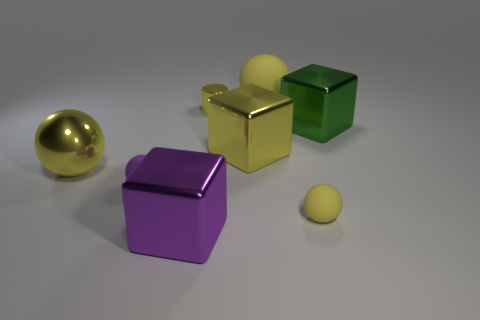There is a green metallic cube; is its size the same as the shiny object that is behind the big green shiny thing?
Your answer should be very brief. No. Are there more metal cylinders left of the tiny shiny cylinder than big yellow rubber balls?
Provide a short and direct response. No. There is a purple cube that is made of the same material as the big yellow cube; what is its size?
Make the answer very short. Large. Are there any metal cubes of the same color as the shiny ball?
Make the answer very short. Yes. How many things are either tiny yellow metal cylinders or small yellow things that are right of the cylinder?
Offer a very short reply. 2. Are there more big red balls than balls?
Offer a very short reply. No. What size is the shiny cube that is the same color as the metal cylinder?
Keep it short and to the point. Large. Is there a small cube that has the same material as the green object?
Provide a short and direct response. No. There is a object that is both on the right side of the big rubber ball and behind the purple sphere; what is its shape?
Offer a very short reply. Cube. What number of other things are there of the same shape as the big green object?
Your answer should be very brief. 2. 